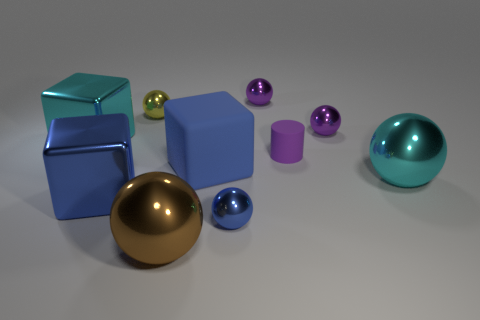The cyan metal ball has what size?
Offer a terse response. Large. What number of brown objects are tiny shiny things or large metal blocks?
Ensure brevity in your answer.  0. What size is the blue metallic object on the left side of the small metallic sphere that is left of the brown object?
Your answer should be very brief. Large. Is the color of the tiny matte object the same as the small sphere to the right of the rubber cylinder?
Your answer should be very brief. Yes. How many other objects are there of the same material as the large cyan cube?
Your answer should be compact. 7. There is a large blue thing that is made of the same material as the cyan cube; what shape is it?
Keep it short and to the point. Cube. Is there any other thing that has the same color as the tiny cylinder?
Provide a succinct answer. Yes. The other cube that is the same color as the rubber block is what size?
Offer a very short reply. Large. Are there more cyan metallic objects that are to the right of the large cyan shiny sphere than large blue rubber things?
Keep it short and to the point. No. There is a tiny rubber thing; does it have the same shape as the big cyan metal thing that is to the right of the tiny purple cylinder?
Your answer should be compact. No. 